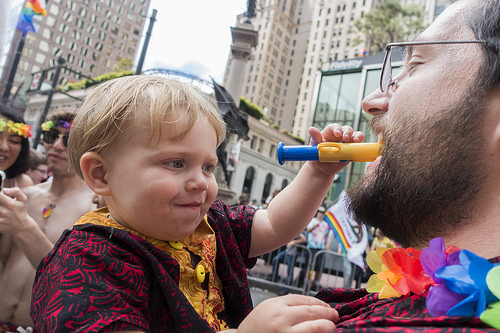<image>
Is there a fence behind the child? Yes. From this viewpoint, the fence is positioned behind the child, with the child partially or fully occluding the fence. 